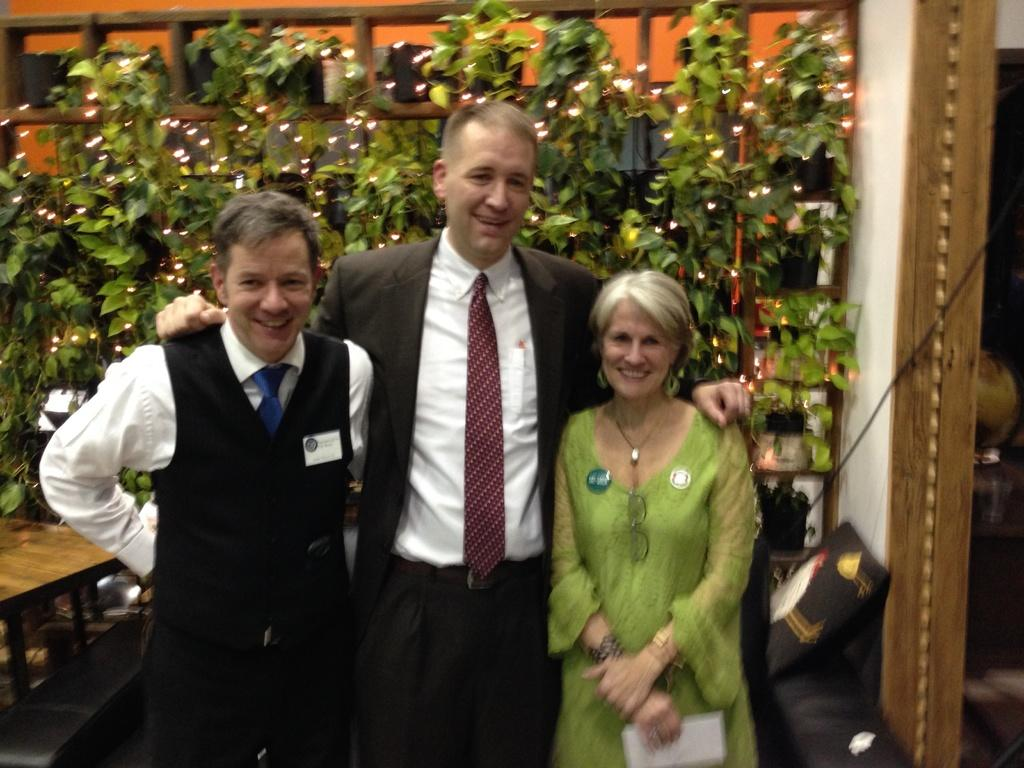What are the people in the image doing? The people in the image are standing and smiling. Can you describe what one person is holding? One person is holding a paper. What can be seen in the background of the image? There is a table, a pillow, a cable, a wall, house plants, and lights in the background of the image. What type of bells can be heard ringing in the image? There are no bells present in the image, and therefore no sound can be heard. Can you describe the net that is visible in the image? There is no net present in the image. 